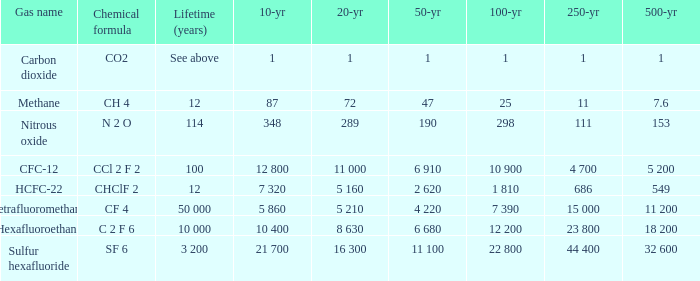What is the 100 year when 500 year is 153? 298.0. 